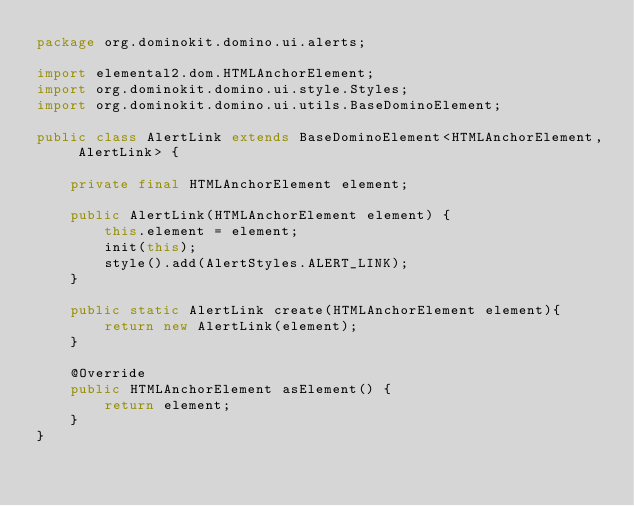Convert code to text. <code><loc_0><loc_0><loc_500><loc_500><_Java_>package org.dominokit.domino.ui.alerts;

import elemental2.dom.HTMLAnchorElement;
import org.dominokit.domino.ui.style.Styles;
import org.dominokit.domino.ui.utils.BaseDominoElement;

public class AlertLink extends BaseDominoElement<HTMLAnchorElement, AlertLink> {

    private final HTMLAnchorElement element;

    public AlertLink(HTMLAnchorElement element) {
        this.element = element;
        init(this);
        style().add(AlertStyles.ALERT_LINK);
    }

    public static AlertLink create(HTMLAnchorElement element){
        return new AlertLink(element);
    }

    @Override
    public HTMLAnchorElement asElement() {
        return element;
    }
}
</code> 